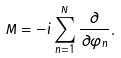Convert formula to latex. <formula><loc_0><loc_0><loc_500><loc_500>\hat { M } = - i \sum _ { n = 1 } ^ { N } \frac { \partial } { \partial \varphi _ { n } } .</formula> 